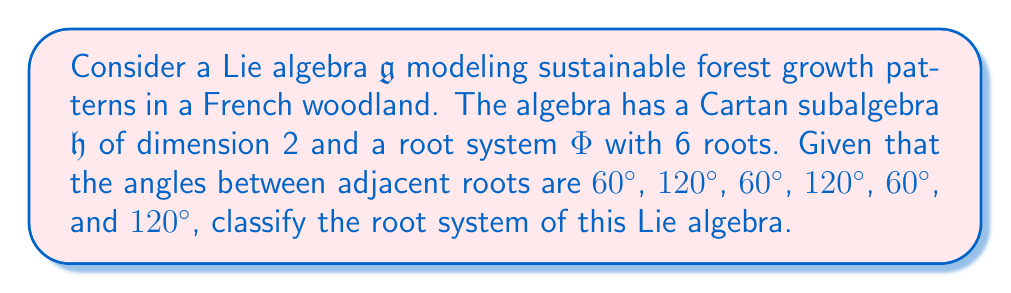Help me with this question. To classify the root system, we'll follow these steps:

1) First, we note that the dimension of the Cartan subalgebra is 2, which means we're dealing with a rank-2 root system.

2) The fact that there are 6 roots and the angles between adjacent roots alternate between 60° and 120° suggests a hexagonal structure.

3) In rank-2 root systems, there are only three possibilities: $A_2$, $B_2$ (equivalent to $C_2$), and $G_2$.

4) The $A_2$ root system has 6 roots forming a regular hexagon, with angles of 60° between short roots and 120° between long roots.

5) The $B_2$ system has 8 roots, so it doesn't match our case.

6) The $G_2$ system has 12 roots, so it also doesn't match.

7) Therefore, by process of elimination and matching characteristics, we can conclude that this root system is of type $A_2$.

8) The $A_2$ root system corresponds to the Lie algebra $\mathfrak{sl}(3,\mathbb{C})$, which can be used to model balanced growth patterns in sustainable forestry.

To visualize this, we can draw the root system:

[asy]
unitsize(1cm);
for(int i=0; i<6; ++i) {
  draw((cos(pi/3*i),sin(pi/3*i))--(cos(pi/3*(i+1)),sin(pi/3*(i+1))), arrow=Arrow(TeXHead));
}
label("$\alpha_1$", (1,0), E);
label("$\alpha_2$", (cos(pi/3),sin(pi/3)), NE);
[/asy]

Here, $\alpha_1$ and $\alpha_2$ are the simple roots, and the other roots are linear combinations of these.
Answer: The root system of the given Lie algebra is of type $A_2$. 